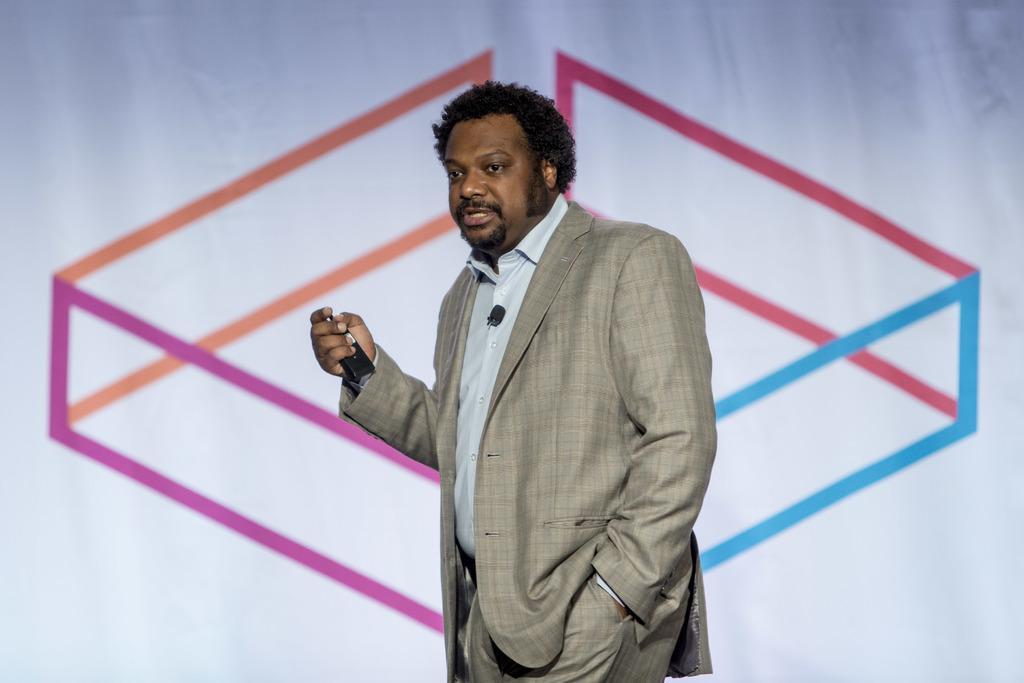Could you give a brief overview of what you see in this image? In the middle of this image, there is a person in a gray color suit, holding a device with a hand and speaking. In the background, there is a painting on a white colored surface. 